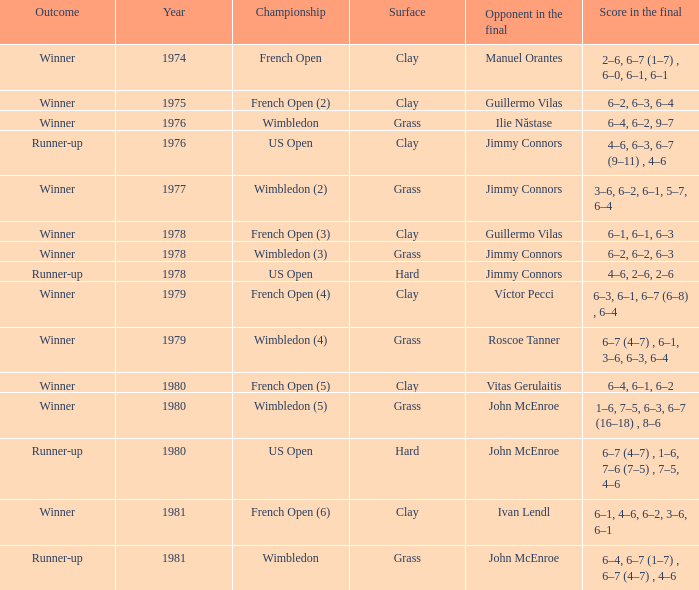What is every score in the final for opponent in final John Mcenroe at US Open? 6–7 (4–7) , 1–6, 7–6 (7–5) , 7–5, 4–6. 